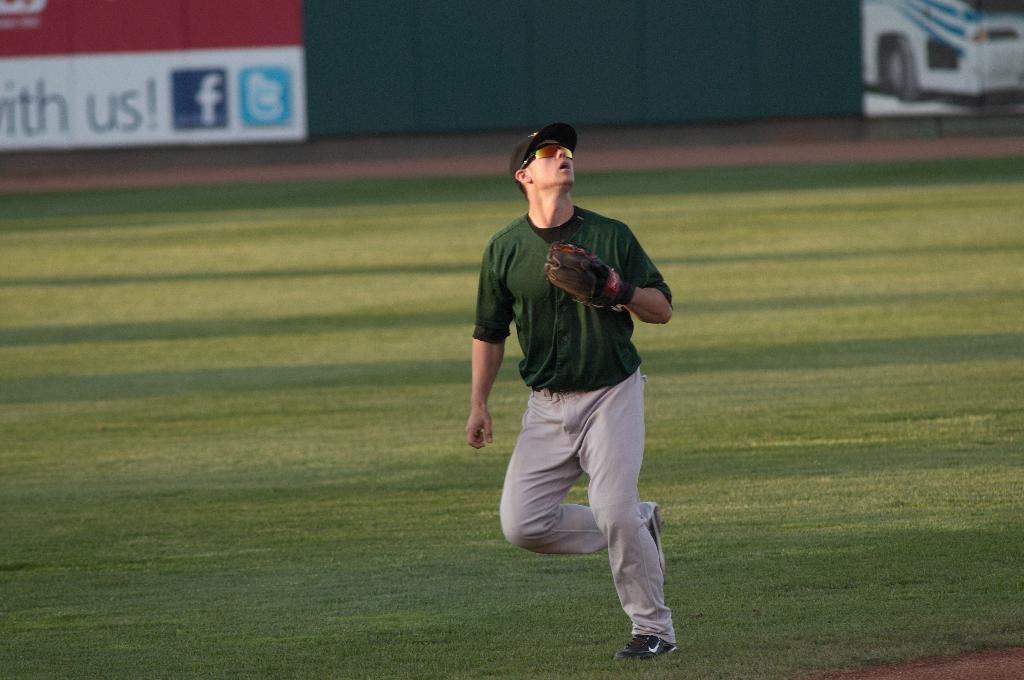<image>
Summarize the visual content of the image. A man is looking up at a baseball in front of an advertisement with a facebook and twitter logo on it. 